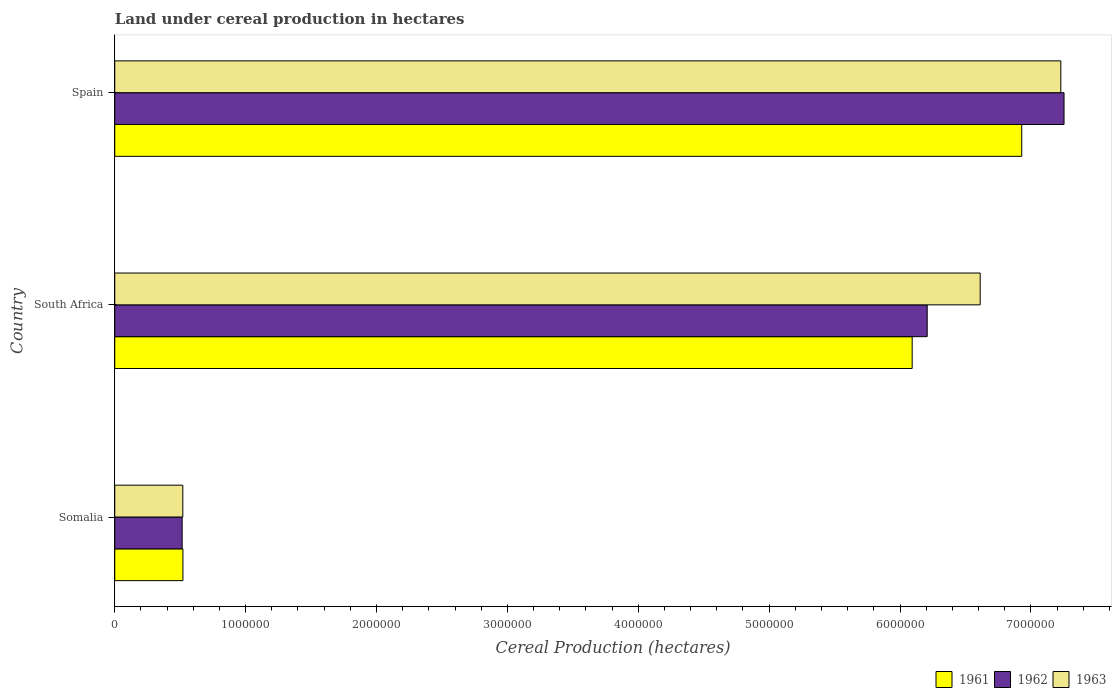How many different coloured bars are there?
Provide a short and direct response. 3. Are the number of bars on each tick of the Y-axis equal?
Provide a short and direct response. Yes. How many bars are there on the 1st tick from the bottom?
Keep it short and to the point. 3. In how many cases, is the number of bars for a given country not equal to the number of legend labels?
Keep it short and to the point. 0. What is the land under cereal production in 1963 in South Africa?
Offer a terse response. 6.61e+06. Across all countries, what is the maximum land under cereal production in 1962?
Your response must be concise. 7.25e+06. Across all countries, what is the minimum land under cereal production in 1963?
Make the answer very short. 5.20e+05. In which country was the land under cereal production in 1962 maximum?
Provide a short and direct response. Spain. In which country was the land under cereal production in 1962 minimum?
Give a very brief answer. Somalia. What is the total land under cereal production in 1961 in the graph?
Your answer should be compact. 1.35e+07. What is the difference between the land under cereal production in 1962 in Somalia and that in South Africa?
Your answer should be very brief. -5.69e+06. What is the difference between the land under cereal production in 1963 in Spain and the land under cereal production in 1961 in Somalia?
Provide a succinct answer. 6.71e+06. What is the average land under cereal production in 1962 per country?
Keep it short and to the point. 4.66e+06. What is the difference between the land under cereal production in 1963 and land under cereal production in 1962 in South Africa?
Keep it short and to the point. 4.05e+05. What is the ratio of the land under cereal production in 1961 in Somalia to that in South Africa?
Provide a succinct answer. 0.09. Is the difference between the land under cereal production in 1963 in South Africa and Spain greater than the difference between the land under cereal production in 1962 in South Africa and Spain?
Make the answer very short. Yes. What is the difference between the highest and the second highest land under cereal production in 1961?
Your answer should be compact. 8.37e+05. What is the difference between the highest and the lowest land under cereal production in 1962?
Provide a short and direct response. 6.74e+06. What does the 3rd bar from the bottom in Somalia represents?
Ensure brevity in your answer.  1963. How many bars are there?
Offer a terse response. 9. Are all the bars in the graph horizontal?
Ensure brevity in your answer.  Yes. Are the values on the major ticks of X-axis written in scientific E-notation?
Your response must be concise. No. Does the graph contain any zero values?
Provide a succinct answer. No. Does the graph contain grids?
Provide a short and direct response. No. How many legend labels are there?
Provide a succinct answer. 3. What is the title of the graph?
Ensure brevity in your answer.  Land under cereal production in hectares. What is the label or title of the X-axis?
Offer a terse response. Cereal Production (hectares). What is the label or title of the Y-axis?
Keep it short and to the point. Country. What is the Cereal Production (hectares) of 1961 in Somalia?
Your response must be concise. 5.21e+05. What is the Cereal Production (hectares) in 1962 in Somalia?
Your response must be concise. 5.15e+05. What is the Cereal Production (hectares) of 1963 in Somalia?
Your response must be concise. 5.20e+05. What is the Cereal Production (hectares) of 1961 in South Africa?
Your answer should be compact. 6.09e+06. What is the Cereal Production (hectares) in 1962 in South Africa?
Your response must be concise. 6.21e+06. What is the Cereal Production (hectares) of 1963 in South Africa?
Offer a terse response. 6.61e+06. What is the Cereal Production (hectares) of 1961 in Spain?
Provide a short and direct response. 6.93e+06. What is the Cereal Production (hectares) of 1962 in Spain?
Provide a succinct answer. 7.25e+06. What is the Cereal Production (hectares) of 1963 in Spain?
Your answer should be compact. 7.23e+06. Across all countries, what is the maximum Cereal Production (hectares) of 1961?
Offer a very short reply. 6.93e+06. Across all countries, what is the maximum Cereal Production (hectares) in 1962?
Make the answer very short. 7.25e+06. Across all countries, what is the maximum Cereal Production (hectares) in 1963?
Your response must be concise. 7.23e+06. Across all countries, what is the minimum Cereal Production (hectares) of 1961?
Provide a succinct answer. 5.21e+05. Across all countries, what is the minimum Cereal Production (hectares) of 1962?
Provide a succinct answer. 5.15e+05. Across all countries, what is the minimum Cereal Production (hectares) of 1963?
Give a very brief answer. 5.20e+05. What is the total Cereal Production (hectares) of 1961 in the graph?
Keep it short and to the point. 1.35e+07. What is the total Cereal Production (hectares) in 1962 in the graph?
Your answer should be compact. 1.40e+07. What is the total Cereal Production (hectares) in 1963 in the graph?
Ensure brevity in your answer.  1.44e+07. What is the difference between the Cereal Production (hectares) of 1961 in Somalia and that in South Africa?
Offer a terse response. -5.57e+06. What is the difference between the Cereal Production (hectares) in 1962 in Somalia and that in South Africa?
Ensure brevity in your answer.  -5.69e+06. What is the difference between the Cereal Production (hectares) in 1963 in Somalia and that in South Africa?
Offer a very short reply. -6.09e+06. What is the difference between the Cereal Production (hectares) in 1961 in Somalia and that in Spain?
Your response must be concise. -6.41e+06. What is the difference between the Cereal Production (hectares) in 1962 in Somalia and that in Spain?
Ensure brevity in your answer.  -6.74e+06. What is the difference between the Cereal Production (hectares) of 1963 in Somalia and that in Spain?
Ensure brevity in your answer.  -6.71e+06. What is the difference between the Cereal Production (hectares) of 1961 in South Africa and that in Spain?
Provide a succinct answer. -8.37e+05. What is the difference between the Cereal Production (hectares) in 1962 in South Africa and that in Spain?
Your answer should be compact. -1.05e+06. What is the difference between the Cereal Production (hectares) in 1963 in South Africa and that in Spain?
Your answer should be compact. -6.16e+05. What is the difference between the Cereal Production (hectares) of 1961 in Somalia and the Cereal Production (hectares) of 1962 in South Africa?
Your response must be concise. -5.69e+06. What is the difference between the Cereal Production (hectares) in 1961 in Somalia and the Cereal Production (hectares) in 1963 in South Africa?
Your response must be concise. -6.09e+06. What is the difference between the Cereal Production (hectares) of 1962 in Somalia and the Cereal Production (hectares) of 1963 in South Africa?
Keep it short and to the point. -6.10e+06. What is the difference between the Cereal Production (hectares) in 1961 in Somalia and the Cereal Production (hectares) in 1962 in Spain?
Your answer should be very brief. -6.73e+06. What is the difference between the Cereal Production (hectares) in 1961 in Somalia and the Cereal Production (hectares) in 1963 in Spain?
Provide a succinct answer. -6.71e+06. What is the difference between the Cereal Production (hectares) in 1962 in Somalia and the Cereal Production (hectares) in 1963 in Spain?
Provide a short and direct response. -6.71e+06. What is the difference between the Cereal Production (hectares) of 1961 in South Africa and the Cereal Production (hectares) of 1962 in Spain?
Provide a short and direct response. -1.16e+06. What is the difference between the Cereal Production (hectares) of 1961 in South Africa and the Cereal Production (hectares) of 1963 in Spain?
Provide a short and direct response. -1.14e+06. What is the difference between the Cereal Production (hectares) of 1962 in South Africa and the Cereal Production (hectares) of 1963 in Spain?
Offer a very short reply. -1.02e+06. What is the average Cereal Production (hectares) in 1961 per country?
Provide a succinct answer. 4.51e+06. What is the average Cereal Production (hectares) of 1962 per country?
Make the answer very short. 4.66e+06. What is the average Cereal Production (hectares) of 1963 per country?
Provide a short and direct response. 4.79e+06. What is the difference between the Cereal Production (hectares) of 1961 and Cereal Production (hectares) of 1962 in Somalia?
Keep it short and to the point. 6000. What is the difference between the Cereal Production (hectares) of 1961 and Cereal Production (hectares) of 1963 in Somalia?
Offer a very short reply. 1000. What is the difference between the Cereal Production (hectares) of 1962 and Cereal Production (hectares) of 1963 in Somalia?
Ensure brevity in your answer.  -5000. What is the difference between the Cereal Production (hectares) in 1961 and Cereal Production (hectares) in 1962 in South Africa?
Provide a succinct answer. -1.15e+05. What is the difference between the Cereal Production (hectares) in 1961 and Cereal Production (hectares) in 1963 in South Africa?
Offer a very short reply. -5.20e+05. What is the difference between the Cereal Production (hectares) of 1962 and Cereal Production (hectares) of 1963 in South Africa?
Offer a very short reply. -4.05e+05. What is the difference between the Cereal Production (hectares) of 1961 and Cereal Production (hectares) of 1962 in Spain?
Your response must be concise. -3.23e+05. What is the difference between the Cereal Production (hectares) of 1961 and Cereal Production (hectares) of 1963 in Spain?
Your response must be concise. -2.99e+05. What is the difference between the Cereal Production (hectares) of 1962 and Cereal Production (hectares) of 1963 in Spain?
Your answer should be very brief. 2.46e+04. What is the ratio of the Cereal Production (hectares) in 1961 in Somalia to that in South Africa?
Ensure brevity in your answer.  0.09. What is the ratio of the Cereal Production (hectares) of 1962 in Somalia to that in South Africa?
Keep it short and to the point. 0.08. What is the ratio of the Cereal Production (hectares) of 1963 in Somalia to that in South Africa?
Provide a succinct answer. 0.08. What is the ratio of the Cereal Production (hectares) of 1961 in Somalia to that in Spain?
Offer a terse response. 0.08. What is the ratio of the Cereal Production (hectares) of 1962 in Somalia to that in Spain?
Give a very brief answer. 0.07. What is the ratio of the Cereal Production (hectares) of 1963 in Somalia to that in Spain?
Ensure brevity in your answer.  0.07. What is the ratio of the Cereal Production (hectares) of 1961 in South Africa to that in Spain?
Provide a succinct answer. 0.88. What is the ratio of the Cereal Production (hectares) of 1962 in South Africa to that in Spain?
Ensure brevity in your answer.  0.86. What is the ratio of the Cereal Production (hectares) in 1963 in South Africa to that in Spain?
Provide a short and direct response. 0.91. What is the difference between the highest and the second highest Cereal Production (hectares) of 1961?
Offer a very short reply. 8.37e+05. What is the difference between the highest and the second highest Cereal Production (hectares) of 1962?
Make the answer very short. 1.05e+06. What is the difference between the highest and the second highest Cereal Production (hectares) in 1963?
Offer a terse response. 6.16e+05. What is the difference between the highest and the lowest Cereal Production (hectares) of 1961?
Provide a succinct answer. 6.41e+06. What is the difference between the highest and the lowest Cereal Production (hectares) in 1962?
Provide a short and direct response. 6.74e+06. What is the difference between the highest and the lowest Cereal Production (hectares) of 1963?
Your answer should be compact. 6.71e+06. 